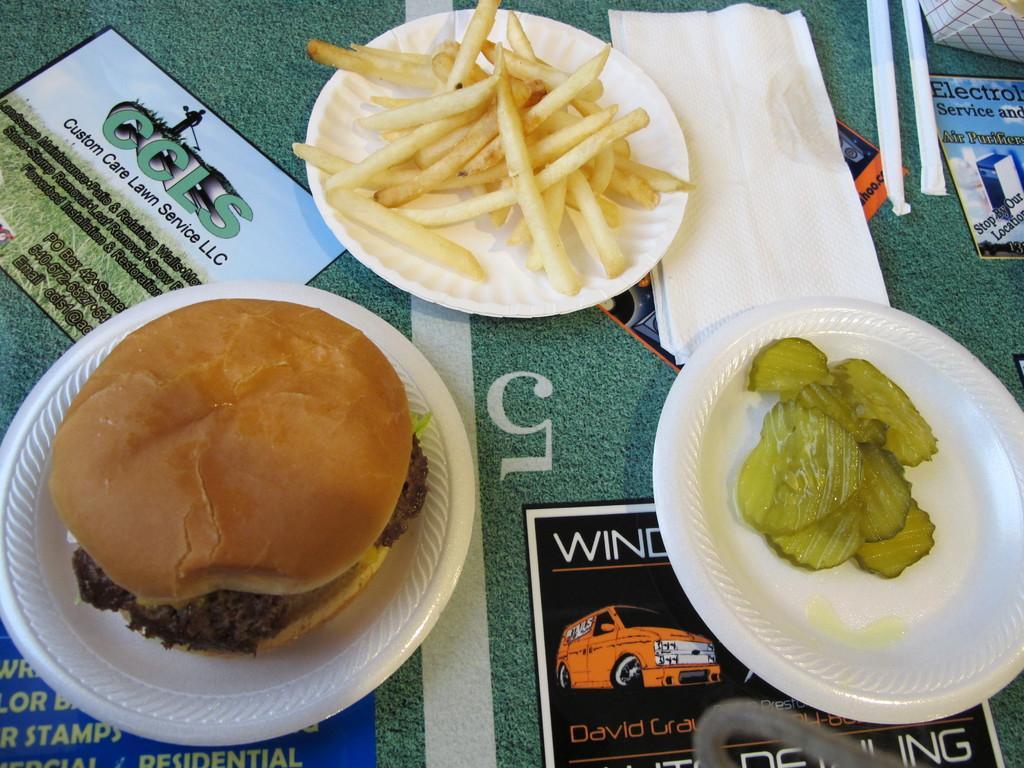In one or two sentences, can you explain what this image depicts? In this picture, we see a plate containing burger, a plate containing french fries and a plate containing fruits are placed on the green table. We even see tissue papers and posters are placed on the table. 